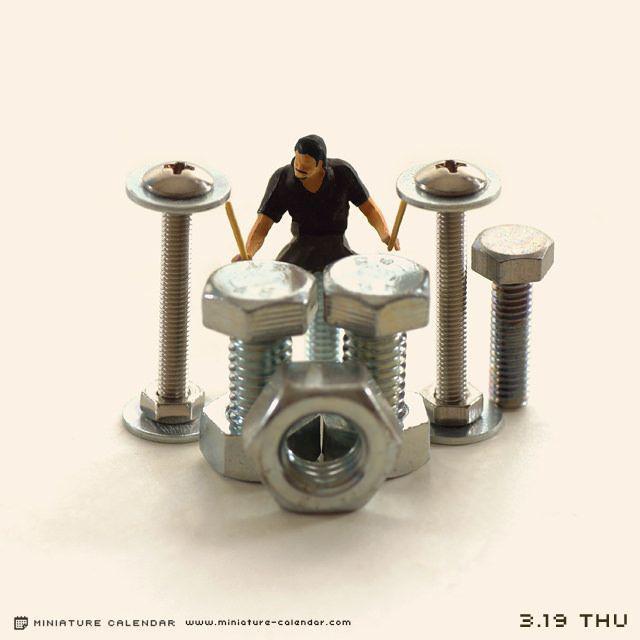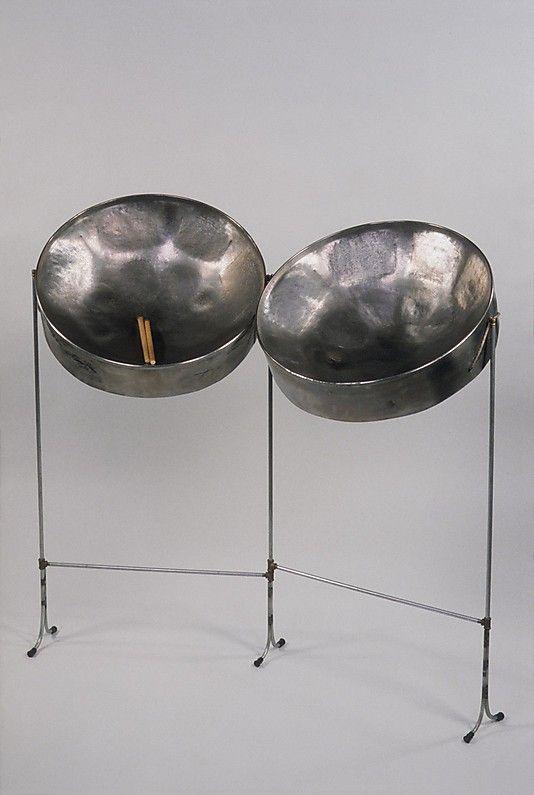The first image is the image on the left, the second image is the image on the right. Analyze the images presented: Is the assertion "At least one steel drum has drum sticks laying on top." valid? Answer yes or no. Yes. The first image is the image on the left, the second image is the image on the right. Analyze the images presented: Is the assertion "In at least one image there is a total of two drums and one man playing them." valid? Answer yes or no. No. 